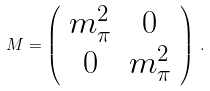<formula> <loc_0><loc_0><loc_500><loc_500>M = \left ( \begin{array} { c c } m ^ { 2 } _ { \pi } & 0 \\ 0 & m _ { \pi } ^ { 2 } \end{array} \right ) \, .</formula> 